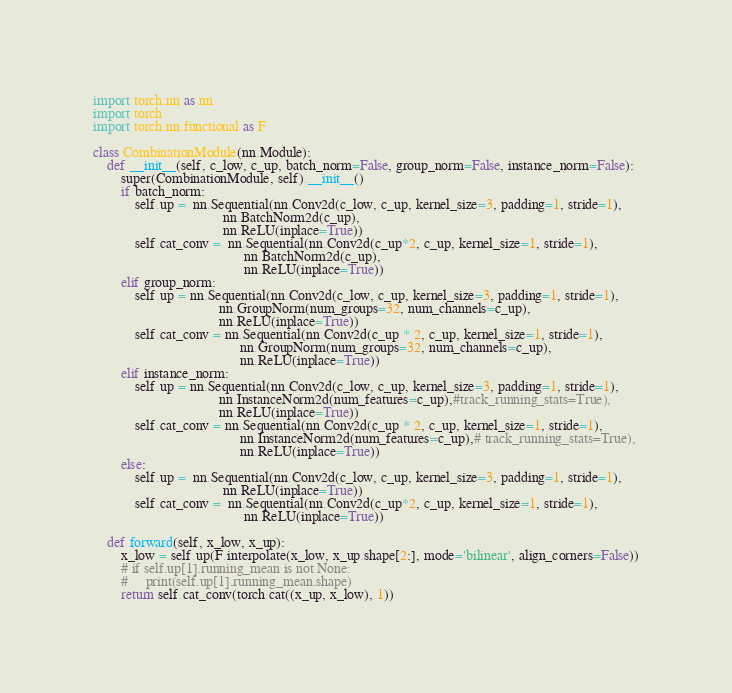<code> <loc_0><loc_0><loc_500><loc_500><_Python_>import torch.nn as nn
import torch
import torch.nn.functional as F

class CombinationModule(nn.Module):
    def __init__(self, c_low, c_up, batch_norm=False, group_norm=False, instance_norm=False):
        super(CombinationModule, self).__init__()
        if batch_norm:
            self.up =  nn.Sequential(nn.Conv2d(c_low, c_up, kernel_size=3, padding=1, stride=1),
                                     nn.BatchNorm2d(c_up),
                                     nn.ReLU(inplace=True))
            self.cat_conv =  nn.Sequential(nn.Conv2d(c_up*2, c_up, kernel_size=1, stride=1),
                                           nn.BatchNorm2d(c_up),
                                           nn.ReLU(inplace=True))
        elif group_norm:
            self.up = nn.Sequential(nn.Conv2d(c_low, c_up, kernel_size=3, padding=1, stride=1),
                                    nn.GroupNorm(num_groups=32, num_channels=c_up),
                                    nn.ReLU(inplace=True))
            self.cat_conv = nn.Sequential(nn.Conv2d(c_up * 2, c_up, kernel_size=1, stride=1),
                                          nn.GroupNorm(num_groups=32, num_channels=c_up),
                                          nn.ReLU(inplace=True))
        elif instance_norm:
            self.up = nn.Sequential(nn.Conv2d(c_low, c_up, kernel_size=3, padding=1, stride=1),
                                    nn.InstanceNorm2d(num_features=c_up),#track_running_stats=True),
                                    nn.ReLU(inplace=True))
            self.cat_conv = nn.Sequential(nn.Conv2d(c_up * 2, c_up, kernel_size=1, stride=1),
                                          nn.InstanceNorm2d(num_features=c_up),# track_running_stats=True),
                                          nn.ReLU(inplace=True))
        else:
            self.up =  nn.Sequential(nn.Conv2d(c_low, c_up, kernel_size=3, padding=1, stride=1),
                                     nn.ReLU(inplace=True))
            self.cat_conv =  nn.Sequential(nn.Conv2d(c_up*2, c_up, kernel_size=1, stride=1),
                                           nn.ReLU(inplace=True))

    def forward(self, x_low, x_up):
        x_low = self.up(F.interpolate(x_low, x_up.shape[2:], mode='bilinear', align_corners=False))
        # if self.up[1].running_mean is not None:
        #     print(self.up[1].running_mean.shape)
        return self.cat_conv(torch.cat((x_up, x_low), 1))
</code> 